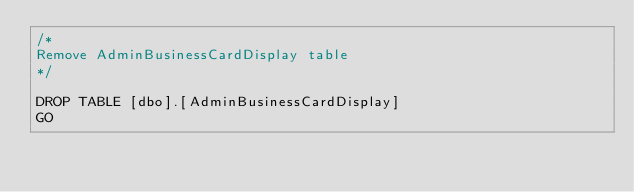<code> <loc_0><loc_0><loc_500><loc_500><_SQL_>/*  
Remove AdminBusinessCardDisplay table
*/

DROP TABLE [dbo].[AdminBusinessCardDisplay]
GO
</code> 